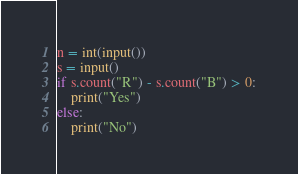<code> <loc_0><loc_0><loc_500><loc_500><_Python_>n = int(input())
s = input()
if s.count("R") - s.count("B") > 0:
    print("Yes")
else:
    print("No")</code> 